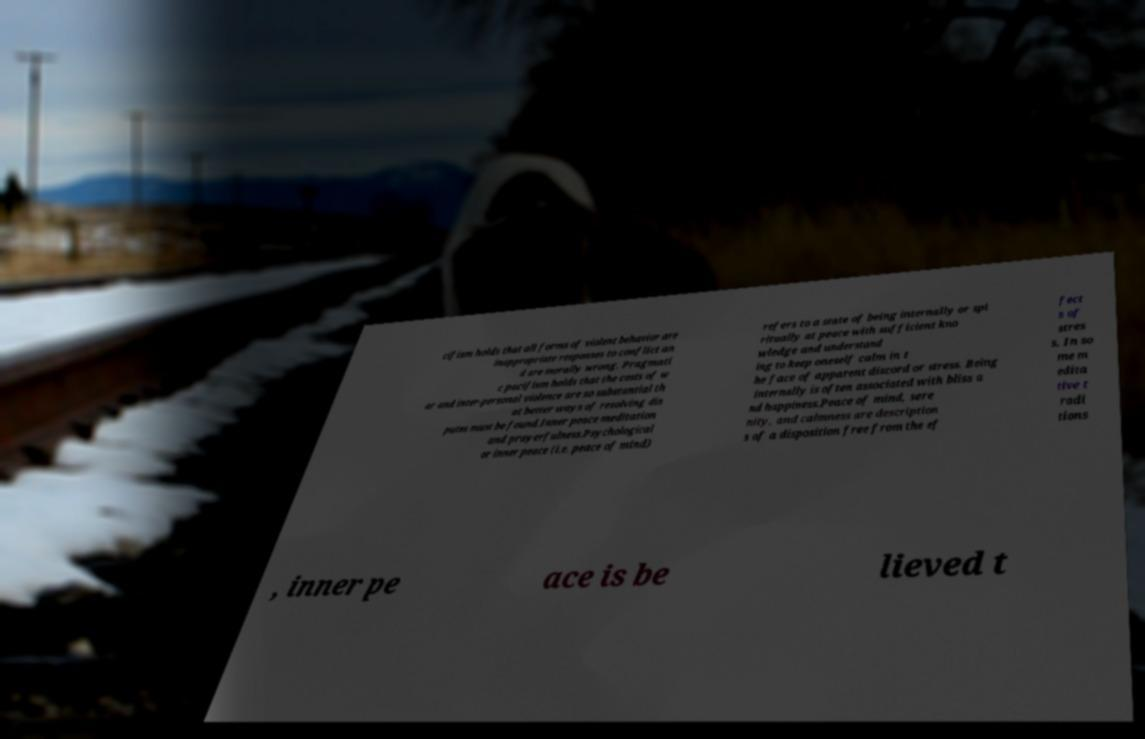For documentation purposes, I need the text within this image transcribed. Could you provide that? cifism holds that all forms of violent behavior are inappropriate responses to conflict an d are morally wrong. Pragmati c pacifism holds that the costs of w ar and inter-personal violence are so substantial th at better ways of resolving dis putes must be found.Inner peace meditation and prayerfulness.Psychological or inner peace (i.e. peace of mind) refers to a state of being internally or spi ritually at peace with sufficient kno wledge and understand ing to keep oneself calm in t he face of apparent discord or stress. Being internally is often associated with bliss a nd happiness.Peace of mind, sere nity, and calmness are description s of a disposition free from the ef fect s of stres s. In so me m edita tive t radi tions , inner pe ace is be lieved t 